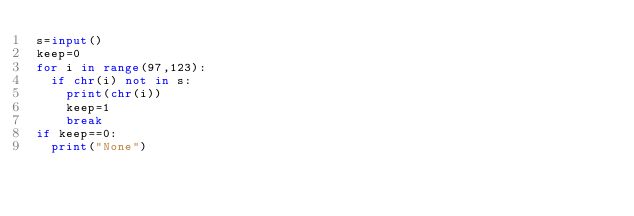<code> <loc_0><loc_0><loc_500><loc_500><_Python_>s=input()
keep=0
for i in range(97,123):
  if chr(i) not in s:
    print(chr(i))
    keep=1
    break
if keep==0:
  print("None")</code> 